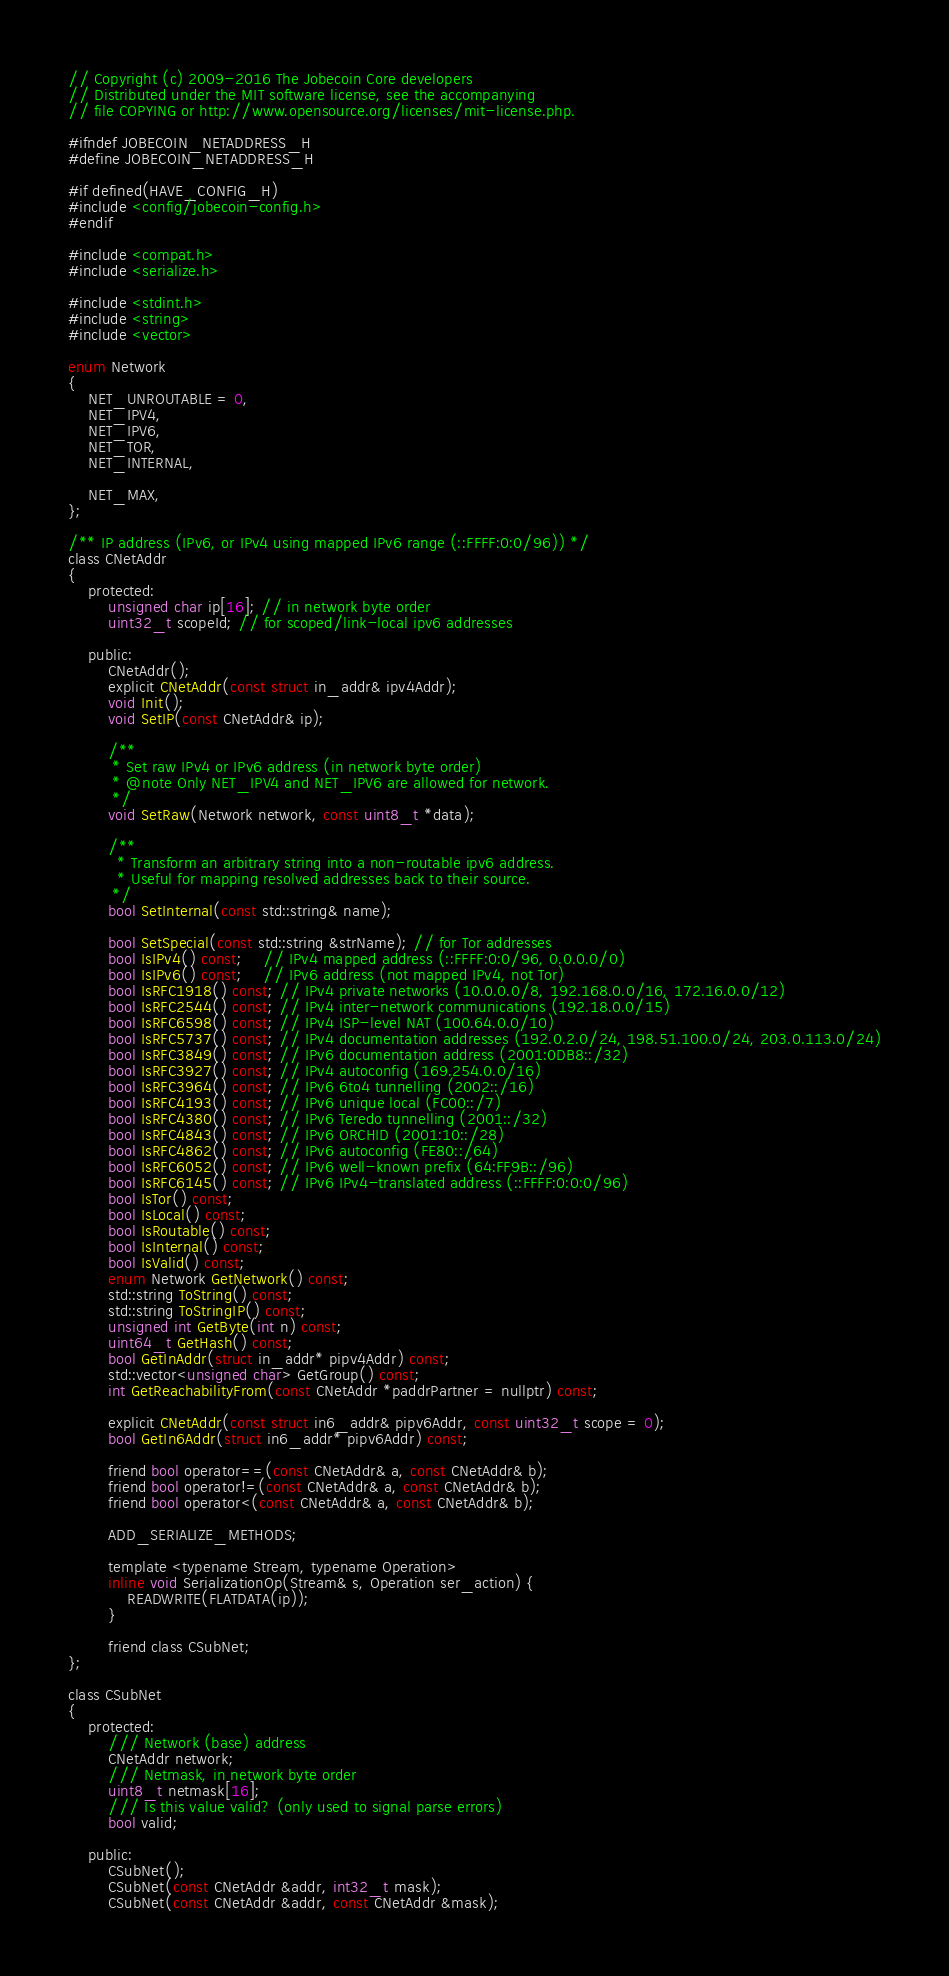Convert code to text. <code><loc_0><loc_0><loc_500><loc_500><_C_>// Copyright (c) 2009-2016 The Jobecoin Core developers
// Distributed under the MIT software license, see the accompanying
// file COPYING or http://www.opensource.org/licenses/mit-license.php.

#ifndef JOBECOIN_NETADDRESS_H
#define JOBECOIN_NETADDRESS_H

#if defined(HAVE_CONFIG_H)
#include <config/jobecoin-config.h>
#endif

#include <compat.h>
#include <serialize.h>

#include <stdint.h>
#include <string>
#include <vector>

enum Network
{
    NET_UNROUTABLE = 0,
    NET_IPV4,
    NET_IPV6,
    NET_TOR,
    NET_INTERNAL,

    NET_MAX,
};

/** IP address (IPv6, or IPv4 using mapped IPv6 range (::FFFF:0:0/96)) */
class CNetAddr
{
    protected:
        unsigned char ip[16]; // in network byte order
        uint32_t scopeId; // for scoped/link-local ipv6 addresses

    public:
        CNetAddr();
        explicit CNetAddr(const struct in_addr& ipv4Addr);
        void Init();
        void SetIP(const CNetAddr& ip);

        /**
         * Set raw IPv4 or IPv6 address (in network byte order)
         * @note Only NET_IPV4 and NET_IPV6 are allowed for network.
         */
        void SetRaw(Network network, const uint8_t *data);

        /**
          * Transform an arbitrary string into a non-routable ipv6 address.
          * Useful for mapping resolved addresses back to their source.
         */
        bool SetInternal(const std::string& name);

        bool SetSpecial(const std::string &strName); // for Tor addresses
        bool IsIPv4() const;    // IPv4 mapped address (::FFFF:0:0/96, 0.0.0.0/0)
        bool IsIPv6() const;    // IPv6 address (not mapped IPv4, not Tor)
        bool IsRFC1918() const; // IPv4 private networks (10.0.0.0/8, 192.168.0.0/16, 172.16.0.0/12)
        bool IsRFC2544() const; // IPv4 inter-network communications (192.18.0.0/15)
        bool IsRFC6598() const; // IPv4 ISP-level NAT (100.64.0.0/10)
        bool IsRFC5737() const; // IPv4 documentation addresses (192.0.2.0/24, 198.51.100.0/24, 203.0.113.0/24)
        bool IsRFC3849() const; // IPv6 documentation address (2001:0DB8::/32)
        bool IsRFC3927() const; // IPv4 autoconfig (169.254.0.0/16)
        bool IsRFC3964() const; // IPv6 6to4 tunnelling (2002::/16)
        bool IsRFC4193() const; // IPv6 unique local (FC00::/7)
        bool IsRFC4380() const; // IPv6 Teredo tunnelling (2001::/32)
        bool IsRFC4843() const; // IPv6 ORCHID (2001:10::/28)
        bool IsRFC4862() const; // IPv6 autoconfig (FE80::/64)
        bool IsRFC6052() const; // IPv6 well-known prefix (64:FF9B::/96)
        bool IsRFC6145() const; // IPv6 IPv4-translated address (::FFFF:0:0:0/96)
        bool IsTor() const;
        bool IsLocal() const;
        bool IsRoutable() const;
        bool IsInternal() const;
        bool IsValid() const;
        enum Network GetNetwork() const;
        std::string ToString() const;
        std::string ToStringIP() const;
        unsigned int GetByte(int n) const;
        uint64_t GetHash() const;
        bool GetInAddr(struct in_addr* pipv4Addr) const;
        std::vector<unsigned char> GetGroup() const;
        int GetReachabilityFrom(const CNetAddr *paddrPartner = nullptr) const;

        explicit CNetAddr(const struct in6_addr& pipv6Addr, const uint32_t scope = 0);
        bool GetIn6Addr(struct in6_addr* pipv6Addr) const;

        friend bool operator==(const CNetAddr& a, const CNetAddr& b);
        friend bool operator!=(const CNetAddr& a, const CNetAddr& b);
        friend bool operator<(const CNetAddr& a, const CNetAddr& b);

        ADD_SERIALIZE_METHODS;

        template <typename Stream, typename Operation>
        inline void SerializationOp(Stream& s, Operation ser_action) {
            READWRITE(FLATDATA(ip));
        }

        friend class CSubNet;
};

class CSubNet
{
    protected:
        /// Network (base) address
        CNetAddr network;
        /// Netmask, in network byte order
        uint8_t netmask[16];
        /// Is this value valid? (only used to signal parse errors)
        bool valid;

    public:
        CSubNet();
        CSubNet(const CNetAddr &addr, int32_t mask);
        CSubNet(const CNetAddr &addr, const CNetAddr &mask);
</code> 